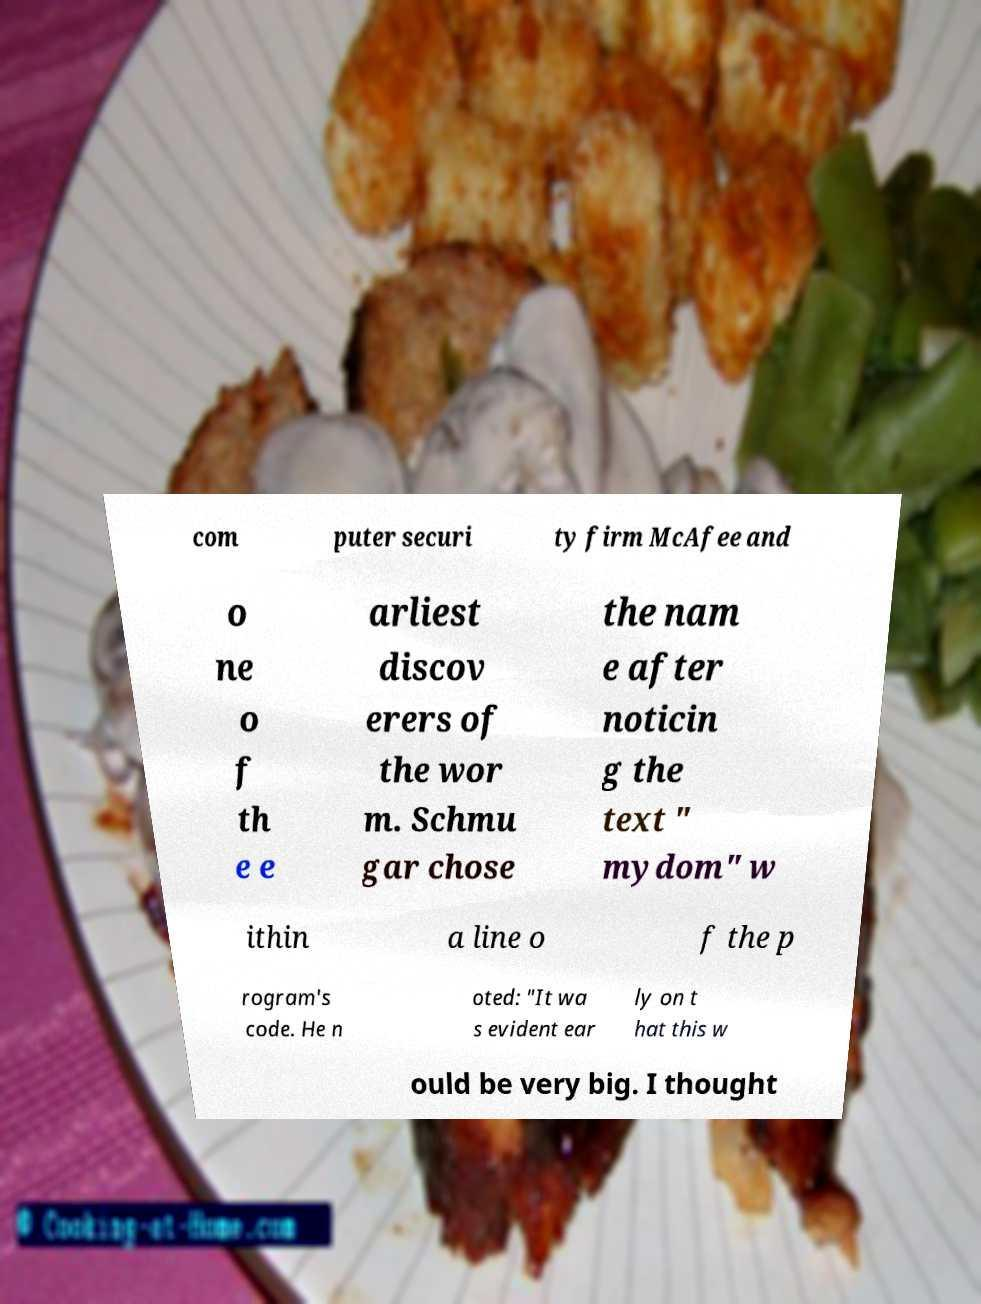There's text embedded in this image that I need extracted. Can you transcribe it verbatim? com puter securi ty firm McAfee and o ne o f th e e arliest discov erers of the wor m. Schmu gar chose the nam e after noticin g the text " mydom" w ithin a line o f the p rogram's code. He n oted: "It wa s evident ear ly on t hat this w ould be very big. I thought 